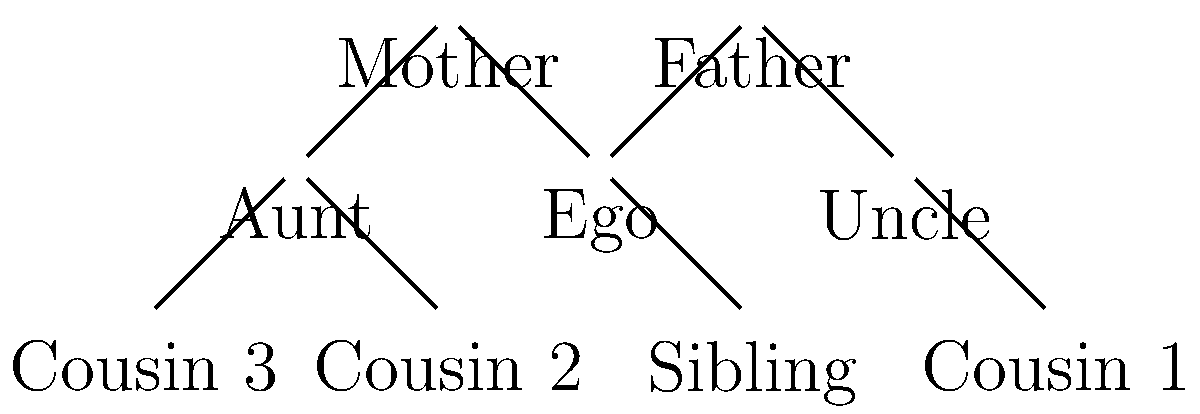As an anthropology student studying tribal societies, analyze the kinship chart provided. Which individuals in this chart would be considered part of Ego's nuclear family in most Western societies, and how might this differ in a matrilineal tribal society? To answer this question, let's break it down step-by-step:

1. Understanding nuclear family in Western societies:
   - In most Western societies, the nuclear family typically consists of parents and their children.
   - From the chart, Ego's nuclear family would include: Ego, Father, Mother, and Sibling.

2. Identifying the nuclear family members in the chart:
   - Ego is the central figure
   - Father and Mother are directly connected to Ego
   - Sibling is also directly connected to Ego and shares the same parents

3. Understanding matrilineal societies:
   - In matrilineal societies, lineage and inheritance are traced through the mother's line.
   - The mother's family often plays a more significant role in a child's life.

4. Considering differences in a matrilineal tribal society:
   - The nuclear family might extend to include the Mother's siblings (Aunt in this chart).
   - Cousins on the mother's side (Cousin 2 and Cousin 3) might be considered closer family members.
   - The Father's relatives (Uncle and Cousin 1) might be considered less significant in terms of family structure.

5. Key differences:
   - Increased importance of maternal relatives
   - Possible inclusion of maternal aunt and cousins in the core family unit
   - Potential decreased emphasis on paternal relatives

This analysis demonstrates how kinship structures can vary significantly between Western and tribal societies, particularly those with matrilineal systems.
Answer: Western nuclear family: Ego, Father, Mother, Sibling. Matrilineal tribal difference: Includes Mother's siblings and their children, emphasizing maternal lineage. 